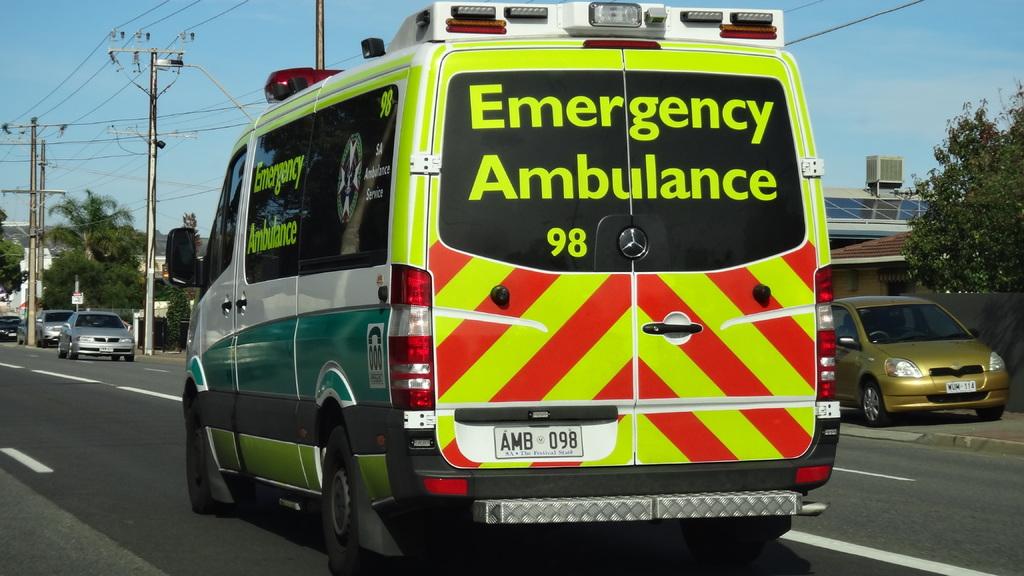What number is written on the back of the ambulance in green letters?
Your answer should be compact. 98. 